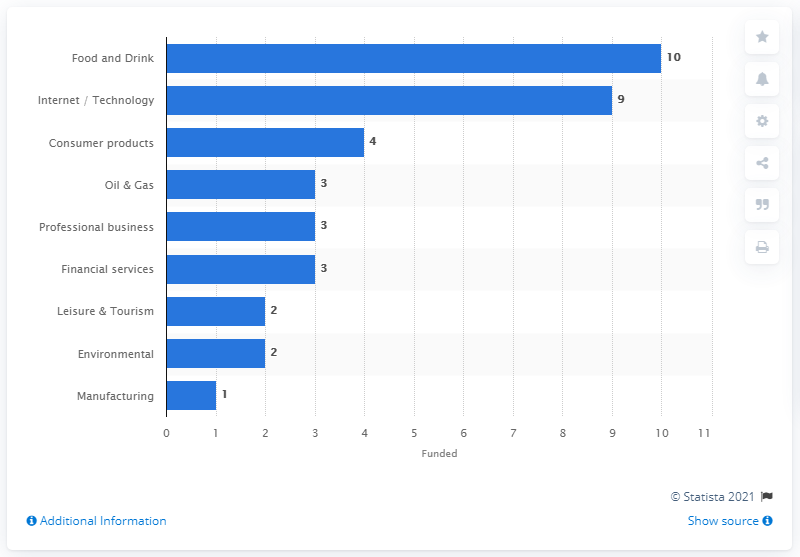Mention a couple of crucial points in this snapshot. In February 2013, a total of 10 ventures in the food and drink category were funded on Crowdcube. 